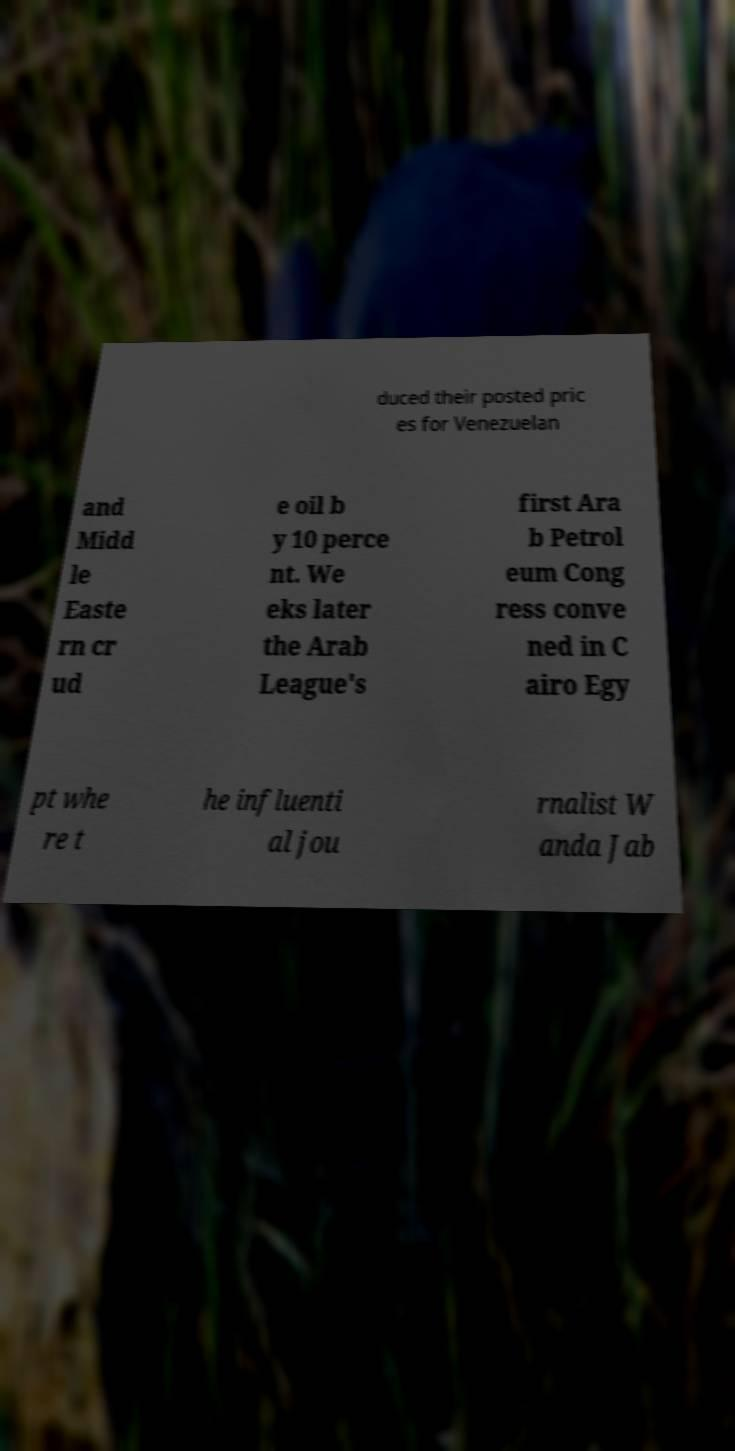Can you accurately transcribe the text from the provided image for me? duced their posted pric es for Venezuelan and Midd le Easte rn cr ud e oil b y 10 perce nt. We eks later the Arab League's first Ara b Petrol eum Cong ress conve ned in C airo Egy pt whe re t he influenti al jou rnalist W anda Jab 